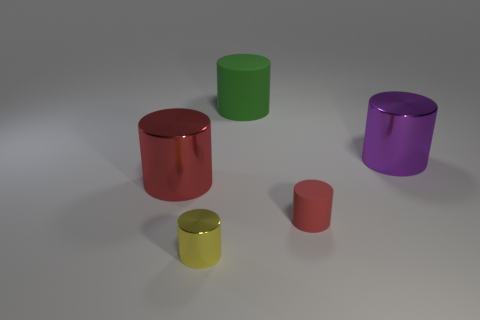How many other objects are the same material as the small red object?
Provide a short and direct response. 1. There is a large shiny thing that is on the right side of the yellow cylinder; is it the same color as the small metallic cylinder?
Keep it short and to the point. No. There is a large shiny cylinder that is behind the big red metallic cylinder; are there any large purple things that are on the right side of it?
Offer a very short reply. No. What is the material of the cylinder that is in front of the large purple metallic cylinder and behind the red matte thing?
Your answer should be compact. Metal. The small red thing that is made of the same material as the green cylinder is what shape?
Give a very brief answer. Cylinder. Is there anything else that has the same shape as the red shiny thing?
Your answer should be compact. Yes. Is the tiny thing that is to the left of the red matte object made of the same material as the purple cylinder?
Offer a very short reply. Yes. There is a large thing right of the tiny red matte thing; what material is it?
Make the answer very short. Metal. What size is the matte cylinder behind the large metal object that is to the right of the large green rubber object?
Keep it short and to the point. Large. How many green objects are the same size as the red shiny cylinder?
Provide a succinct answer. 1. 